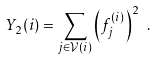Convert formula to latex. <formula><loc_0><loc_0><loc_500><loc_500>Y _ { 2 } ( i ) = \sum _ { j \in \mathcal { V } ( i ) } { \left ( f _ { j } ^ { ( i ) } \right ) } ^ { 2 } \ .</formula> 